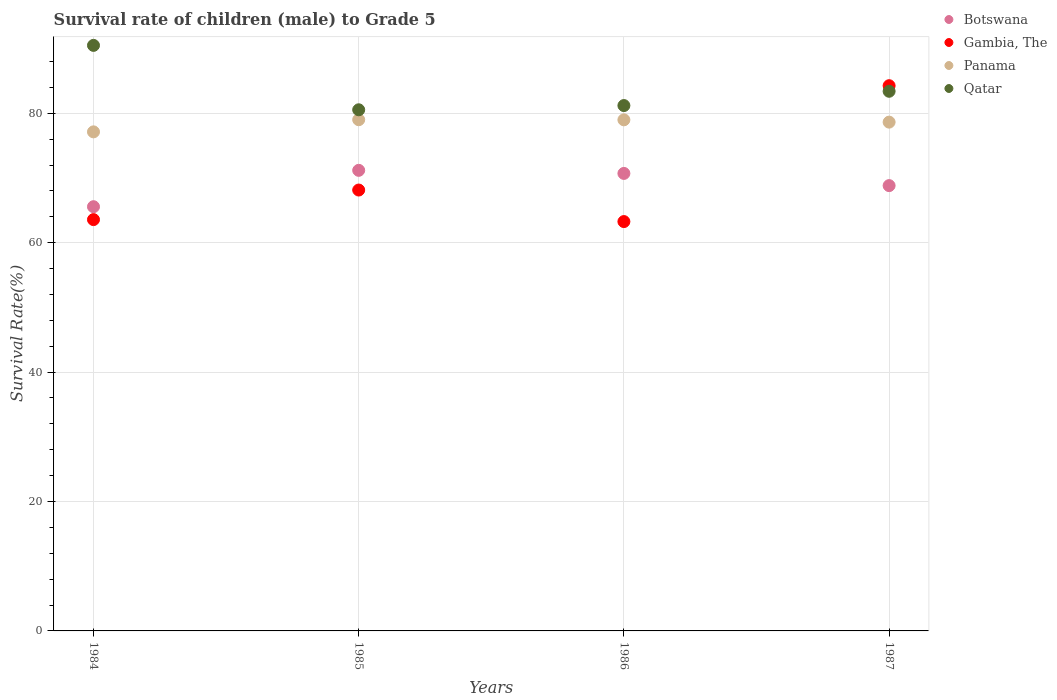How many different coloured dotlines are there?
Offer a very short reply. 4. Is the number of dotlines equal to the number of legend labels?
Your answer should be very brief. Yes. What is the survival rate of male children to grade 5 in Panama in 1987?
Offer a very short reply. 78.63. Across all years, what is the maximum survival rate of male children to grade 5 in Botswana?
Your response must be concise. 71.18. Across all years, what is the minimum survival rate of male children to grade 5 in Botswana?
Provide a succinct answer. 65.56. In which year was the survival rate of male children to grade 5 in Qatar maximum?
Provide a short and direct response. 1984. In which year was the survival rate of male children to grade 5 in Qatar minimum?
Ensure brevity in your answer.  1985. What is the total survival rate of male children to grade 5 in Panama in the graph?
Make the answer very short. 313.76. What is the difference between the survival rate of male children to grade 5 in Gambia, The in 1984 and that in 1987?
Ensure brevity in your answer.  -20.7. What is the difference between the survival rate of male children to grade 5 in Gambia, The in 1984 and the survival rate of male children to grade 5 in Panama in 1986?
Provide a succinct answer. -15.42. What is the average survival rate of male children to grade 5 in Qatar per year?
Offer a very short reply. 83.91. In the year 1986, what is the difference between the survival rate of male children to grade 5 in Panama and survival rate of male children to grade 5 in Qatar?
Your answer should be very brief. -2.21. What is the ratio of the survival rate of male children to grade 5 in Gambia, The in 1985 to that in 1987?
Your answer should be very brief. 0.81. Is the survival rate of male children to grade 5 in Qatar in 1984 less than that in 1986?
Give a very brief answer. No. Is the difference between the survival rate of male children to grade 5 in Panama in 1984 and 1987 greater than the difference between the survival rate of male children to grade 5 in Qatar in 1984 and 1987?
Provide a succinct answer. No. What is the difference between the highest and the second highest survival rate of male children to grade 5 in Panama?
Offer a very short reply. 0.02. What is the difference between the highest and the lowest survival rate of male children to grade 5 in Panama?
Your response must be concise. 1.88. In how many years, is the survival rate of male children to grade 5 in Gambia, The greater than the average survival rate of male children to grade 5 in Gambia, The taken over all years?
Provide a succinct answer. 1. Is it the case that in every year, the sum of the survival rate of male children to grade 5 in Qatar and survival rate of male children to grade 5 in Panama  is greater than the survival rate of male children to grade 5 in Botswana?
Make the answer very short. Yes. Does the survival rate of male children to grade 5 in Botswana monotonically increase over the years?
Offer a very short reply. No. Is the survival rate of male children to grade 5 in Botswana strictly greater than the survival rate of male children to grade 5 in Qatar over the years?
Keep it short and to the point. No. How many dotlines are there?
Ensure brevity in your answer.  4. How many years are there in the graph?
Keep it short and to the point. 4. What is the difference between two consecutive major ticks on the Y-axis?
Offer a terse response. 20. Are the values on the major ticks of Y-axis written in scientific E-notation?
Ensure brevity in your answer.  No. Does the graph contain any zero values?
Give a very brief answer. No. Where does the legend appear in the graph?
Offer a terse response. Top right. How are the legend labels stacked?
Offer a terse response. Vertical. What is the title of the graph?
Your answer should be compact. Survival rate of children (male) to Grade 5. What is the label or title of the Y-axis?
Give a very brief answer. Survival Rate(%). What is the Survival Rate(%) in Botswana in 1984?
Your answer should be very brief. 65.56. What is the Survival Rate(%) in Gambia, The in 1984?
Provide a short and direct response. 63.57. What is the Survival Rate(%) of Panama in 1984?
Your answer should be compact. 77.13. What is the Survival Rate(%) in Qatar in 1984?
Ensure brevity in your answer.  90.49. What is the Survival Rate(%) of Botswana in 1985?
Give a very brief answer. 71.18. What is the Survival Rate(%) of Gambia, The in 1985?
Offer a terse response. 68.14. What is the Survival Rate(%) of Panama in 1985?
Make the answer very short. 79.01. What is the Survival Rate(%) in Qatar in 1985?
Ensure brevity in your answer.  80.54. What is the Survival Rate(%) of Botswana in 1986?
Ensure brevity in your answer.  70.71. What is the Survival Rate(%) in Gambia, The in 1986?
Ensure brevity in your answer.  63.26. What is the Survival Rate(%) in Panama in 1986?
Offer a very short reply. 78.99. What is the Survival Rate(%) in Qatar in 1986?
Offer a terse response. 81.19. What is the Survival Rate(%) in Botswana in 1987?
Ensure brevity in your answer.  68.82. What is the Survival Rate(%) in Gambia, The in 1987?
Give a very brief answer. 84.26. What is the Survival Rate(%) in Panama in 1987?
Your response must be concise. 78.63. What is the Survival Rate(%) of Qatar in 1987?
Your answer should be very brief. 83.4. Across all years, what is the maximum Survival Rate(%) of Botswana?
Keep it short and to the point. 71.18. Across all years, what is the maximum Survival Rate(%) in Gambia, The?
Provide a succinct answer. 84.26. Across all years, what is the maximum Survival Rate(%) of Panama?
Your answer should be very brief. 79.01. Across all years, what is the maximum Survival Rate(%) in Qatar?
Provide a succinct answer. 90.49. Across all years, what is the minimum Survival Rate(%) in Botswana?
Provide a short and direct response. 65.56. Across all years, what is the minimum Survival Rate(%) of Gambia, The?
Your answer should be very brief. 63.26. Across all years, what is the minimum Survival Rate(%) of Panama?
Offer a very short reply. 77.13. Across all years, what is the minimum Survival Rate(%) in Qatar?
Your answer should be very brief. 80.54. What is the total Survival Rate(%) in Botswana in the graph?
Your response must be concise. 276.27. What is the total Survival Rate(%) of Gambia, The in the graph?
Provide a succinct answer. 279.23. What is the total Survival Rate(%) of Panama in the graph?
Make the answer very short. 313.76. What is the total Survival Rate(%) in Qatar in the graph?
Make the answer very short. 335.63. What is the difference between the Survival Rate(%) in Botswana in 1984 and that in 1985?
Give a very brief answer. -5.62. What is the difference between the Survival Rate(%) of Gambia, The in 1984 and that in 1985?
Provide a succinct answer. -4.57. What is the difference between the Survival Rate(%) of Panama in 1984 and that in 1985?
Make the answer very short. -1.88. What is the difference between the Survival Rate(%) of Qatar in 1984 and that in 1985?
Provide a succinct answer. 9.95. What is the difference between the Survival Rate(%) in Botswana in 1984 and that in 1986?
Ensure brevity in your answer.  -5.14. What is the difference between the Survival Rate(%) of Gambia, The in 1984 and that in 1986?
Your answer should be compact. 0.3. What is the difference between the Survival Rate(%) in Panama in 1984 and that in 1986?
Your answer should be very brief. -1.86. What is the difference between the Survival Rate(%) of Qatar in 1984 and that in 1986?
Keep it short and to the point. 9.3. What is the difference between the Survival Rate(%) in Botswana in 1984 and that in 1987?
Offer a terse response. -3.26. What is the difference between the Survival Rate(%) in Gambia, The in 1984 and that in 1987?
Offer a terse response. -20.7. What is the difference between the Survival Rate(%) in Panama in 1984 and that in 1987?
Ensure brevity in your answer.  -1.5. What is the difference between the Survival Rate(%) of Qatar in 1984 and that in 1987?
Provide a succinct answer. 7.09. What is the difference between the Survival Rate(%) of Botswana in 1985 and that in 1986?
Provide a short and direct response. 0.48. What is the difference between the Survival Rate(%) of Gambia, The in 1985 and that in 1986?
Provide a short and direct response. 4.87. What is the difference between the Survival Rate(%) in Panama in 1985 and that in 1986?
Offer a terse response. 0.02. What is the difference between the Survival Rate(%) of Qatar in 1985 and that in 1986?
Ensure brevity in your answer.  -0.65. What is the difference between the Survival Rate(%) in Botswana in 1985 and that in 1987?
Give a very brief answer. 2.36. What is the difference between the Survival Rate(%) of Gambia, The in 1985 and that in 1987?
Your answer should be compact. -16.12. What is the difference between the Survival Rate(%) of Panama in 1985 and that in 1987?
Your answer should be very brief. 0.37. What is the difference between the Survival Rate(%) in Qatar in 1985 and that in 1987?
Ensure brevity in your answer.  -2.86. What is the difference between the Survival Rate(%) in Botswana in 1986 and that in 1987?
Give a very brief answer. 1.88. What is the difference between the Survival Rate(%) in Gambia, The in 1986 and that in 1987?
Your answer should be compact. -21. What is the difference between the Survival Rate(%) in Panama in 1986 and that in 1987?
Your answer should be very brief. 0.36. What is the difference between the Survival Rate(%) in Qatar in 1986 and that in 1987?
Give a very brief answer. -2.21. What is the difference between the Survival Rate(%) in Botswana in 1984 and the Survival Rate(%) in Gambia, The in 1985?
Your answer should be very brief. -2.58. What is the difference between the Survival Rate(%) in Botswana in 1984 and the Survival Rate(%) in Panama in 1985?
Provide a succinct answer. -13.45. What is the difference between the Survival Rate(%) of Botswana in 1984 and the Survival Rate(%) of Qatar in 1985?
Your answer should be very brief. -14.98. What is the difference between the Survival Rate(%) of Gambia, The in 1984 and the Survival Rate(%) of Panama in 1985?
Provide a short and direct response. -15.44. What is the difference between the Survival Rate(%) of Gambia, The in 1984 and the Survival Rate(%) of Qatar in 1985?
Your answer should be very brief. -16.97. What is the difference between the Survival Rate(%) in Panama in 1984 and the Survival Rate(%) in Qatar in 1985?
Keep it short and to the point. -3.41. What is the difference between the Survival Rate(%) in Botswana in 1984 and the Survival Rate(%) in Gambia, The in 1986?
Offer a very short reply. 2.3. What is the difference between the Survival Rate(%) of Botswana in 1984 and the Survival Rate(%) of Panama in 1986?
Provide a succinct answer. -13.43. What is the difference between the Survival Rate(%) in Botswana in 1984 and the Survival Rate(%) in Qatar in 1986?
Your answer should be very brief. -15.63. What is the difference between the Survival Rate(%) of Gambia, The in 1984 and the Survival Rate(%) of Panama in 1986?
Keep it short and to the point. -15.42. What is the difference between the Survival Rate(%) in Gambia, The in 1984 and the Survival Rate(%) in Qatar in 1986?
Offer a terse response. -17.63. What is the difference between the Survival Rate(%) of Panama in 1984 and the Survival Rate(%) of Qatar in 1986?
Provide a short and direct response. -4.07. What is the difference between the Survival Rate(%) of Botswana in 1984 and the Survival Rate(%) of Gambia, The in 1987?
Keep it short and to the point. -18.7. What is the difference between the Survival Rate(%) in Botswana in 1984 and the Survival Rate(%) in Panama in 1987?
Make the answer very short. -13.07. What is the difference between the Survival Rate(%) in Botswana in 1984 and the Survival Rate(%) in Qatar in 1987?
Offer a very short reply. -17.84. What is the difference between the Survival Rate(%) in Gambia, The in 1984 and the Survival Rate(%) in Panama in 1987?
Give a very brief answer. -15.07. What is the difference between the Survival Rate(%) of Gambia, The in 1984 and the Survival Rate(%) of Qatar in 1987?
Make the answer very short. -19.83. What is the difference between the Survival Rate(%) of Panama in 1984 and the Survival Rate(%) of Qatar in 1987?
Offer a very short reply. -6.27. What is the difference between the Survival Rate(%) of Botswana in 1985 and the Survival Rate(%) of Gambia, The in 1986?
Make the answer very short. 7.92. What is the difference between the Survival Rate(%) of Botswana in 1985 and the Survival Rate(%) of Panama in 1986?
Ensure brevity in your answer.  -7.81. What is the difference between the Survival Rate(%) in Botswana in 1985 and the Survival Rate(%) in Qatar in 1986?
Your response must be concise. -10.01. What is the difference between the Survival Rate(%) in Gambia, The in 1985 and the Survival Rate(%) in Panama in 1986?
Ensure brevity in your answer.  -10.85. What is the difference between the Survival Rate(%) of Gambia, The in 1985 and the Survival Rate(%) of Qatar in 1986?
Make the answer very short. -13.06. What is the difference between the Survival Rate(%) of Panama in 1985 and the Survival Rate(%) of Qatar in 1986?
Your answer should be very brief. -2.19. What is the difference between the Survival Rate(%) of Botswana in 1985 and the Survival Rate(%) of Gambia, The in 1987?
Offer a very short reply. -13.08. What is the difference between the Survival Rate(%) of Botswana in 1985 and the Survival Rate(%) of Panama in 1987?
Give a very brief answer. -7.45. What is the difference between the Survival Rate(%) in Botswana in 1985 and the Survival Rate(%) in Qatar in 1987?
Make the answer very short. -12.22. What is the difference between the Survival Rate(%) of Gambia, The in 1985 and the Survival Rate(%) of Panama in 1987?
Make the answer very short. -10.49. What is the difference between the Survival Rate(%) in Gambia, The in 1985 and the Survival Rate(%) in Qatar in 1987?
Provide a succinct answer. -15.26. What is the difference between the Survival Rate(%) of Panama in 1985 and the Survival Rate(%) of Qatar in 1987?
Your answer should be compact. -4.39. What is the difference between the Survival Rate(%) of Botswana in 1986 and the Survival Rate(%) of Gambia, The in 1987?
Offer a very short reply. -13.56. What is the difference between the Survival Rate(%) in Botswana in 1986 and the Survival Rate(%) in Panama in 1987?
Your response must be concise. -7.93. What is the difference between the Survival Rate(%) of Botswana in 1986 and the Survival Rate(%) of Qatar in 1987?
Your response must be concise. -12.69. What is the difference between the Survival Rate(%) of Gambia, The in 1986 and the Survival Rate(%) of Panama in 1987?
Offer a very short reply. -15.37. What is the difference between the Survival Rate(%) of Gambia, The in 1986 and the Survival Rate(%) of Qatar in 1987?
Keep it short and to the point. -20.14. What is the difference between the Survival Rate(%) in Panama in 1986 and the Survival Rate(%) in Qatar in 1987?
Keep it short and to the point. -4.41. What is the average Survival Rate(%) in Botswana per year?
Your response must be concise. 69.07. What is the average Survival Rate(%) of Gambia, The per year?
Your response must be concise. 69.81. What is the average Survival Rate(%) in Panama per year?
Your answer should be compact. 78.44. What is the average Survival Rate(%) of Qatar per year?
Your answer should be very brief. 83.91. In the year 1984, what is the difference between the Survival Rate(%) of Botswana and Survival Rate(%) of Gambia, The?
Your response must be concise. 1.99. In the year 1984, what is the difference between the Survival Rate(%) of Botswana and Survival Rate(%) of Panama?
Provide a succinct answer. -11.57. In the year 1984, what is the difference between the Survival Rate(%) in Botswana and Survival Rate(%) in Qatar?
Your response must be concise. -24.93. In the year 1984, what is the difference between the Survival Rate(%) of Gambia, The and Survival Rate(%) of Panama?
Give a very brief answer. -13.56. In the year 1984, what is the difference between the Survival Rate(%) in Gambia, The and Survival Rate(%) in Qatar?
Your answer should be very brief. -26.93. In the year 1984, what is the difference between the Survival Rate(%) of Panama and Survival Rate(%) of Qatar?
Keep it short and to the point. -13.36. In the year 1985, what is the difference between the Survival Rate(%) of Botswana and Survival Rate(%) of Gambia, The?
Offer a terse response. 3.04. In the year 1985, what is the difference between the Survival Rate(%) in Botswana and Survival Rate(%) in Panama?
Give a very brief answer. -7.82. In the year 1985, what is the difference between the Survival Rate(%) in Botswana and Survival Rate(%) in Qatar?
Provide a succinct answer. -9.36. In the year 1985, what is the difference between the Survival Rate(%) in Gambia, The and Survival Rate(%) in Panama?
Your answer should be compact. -10.87. In the year 1985, what is the difference between the Survival Rate(%) of Gambia, The and Survival Rate(%) of Qatar?
Your answer should be very brief. -12.4. In the year 1985, what is the difference between the Survival Rate(%) in Panama and Survival Rate(%) in Qatar?
Provide a succinct answer. -1.53. In the year 1986, what is the difference between the Survival Rate(%) in Botswana and Survival Rate(%) in Gambia, The?
Offer a very short reply. 7.44. In the year 1986, what is the difference between the Survival Rate(%) in Botswana and Survival Rate(%) in Panama?
Provide a succinct answer. -8.28. In the year 1986, what is the difference between the Survival Rate(%) in Botswana and Survival Rate(%) in Qatar?
Keep it short and to the point. -10.49. In the year 1986, what is the difference between the Survival Rate(%) of Gambia, The and Survival Rate(%) of Panama?
Ensure brevity in your answer.  -15.72. In the year 1986, what is the difference between the Survival Rate(%) in Gambia, The and Survival Rate(%) in Qatar?
Provide a succinct answer. -17.93. In the year 1986, what is the difference between the Survival Rate(%) in Panama and Survival Rate(%) in Qatar?
Give a very brief answer. -2.21. In the year 1987, what is the difference between the Survival Rate(%) of Botswana and Survival Rate(%) of Gambia, The?
Ensure brevity in your answer.  -15.44. In the year 1987, what is the difference between the Survival Rate(%) in Botswana and Survival Rate(%) in Panama?
Ensure brevity in your answer.  -9.81. In the year 1987, what is the difference between the Survival Rate(%) in Botswana and Survival Rate(%) in Qatar?
Provide a short and direct response. -14.58. In the year 1987, what is the difference between the Survival Rate(%) of Gambia, The and Survival Rate(%) of Panama?
Your answer should be very brief. 5.63. In the year 1987, what is the difference between the Survival Rate(%) of Gambia, The and Survival Rate(%) of Qatar?
Provide a short and direct response. 0.86. In the year 1987, what is the difference between the Survival Rate(%) in Panama and Survival Rate(%) in Qatar?
Your response must be concise. -4.77. What is the ratio of the Survival Rate(%) of Botswana in 1984 to that in 1985?
Make the answer very short. 0.92. What is the ratio of the Survival Rate(%) of Gambia, The in 1984 to that in 1985?
Offer a terse response. 0.93. What is the ratio of the Survival Rate(%) in Panama in 1984 to that in 1985?
Ensure brevity in your answer.  0.98. What is the ratio of the Survival Rate(%) in Qatar in 1984 to that in 1985?
Offer a very short reply. 1.12. What is the ratio of the Survival Rate(%) in Botswana in 1984 to that in 1986?
Offer a terse response. 0.93. What is the ratio of the Survival Rate(%) of Gambia, The in 1984 to that in 1986?
Offer a terse response. 1. What is the ratio of the Survival Rate(%) in Panama in 1984 to that in 1986?
Give a very brief answer. 0.98. What is the ratio of the Survival Rate(%) in Qatar in 1984 to that in 1986?
Give a very brief answer. 1.11. What is the ratio of the Survival Rate(%) of Botswana in 1984 to that in 1987?
Offer a terse response. 0.95. What is the ratio of the Survival Rate(%) in Gambia, The in 1984 to that in 1987?
Give a very brief answer. 0.75. What is the ratio of the Survival Rate(%) of Panama in 1984 to that in 1987?
Your response must be concise. 0.98. What is the ratio of the Survival Rate(%) of Qatar in 1984 to that in 1987?
Give a very brief answer. 1.08. What is the ratio of the Survival Rate(%) of Gambia, The in 1985 to that in 1986?
Ensure brevity in your answer.  1.08. What is the ratio of the Survival Rate(%) of Botswana in 1985 to that in 1987?
Make the answer very short. 1.03. What is the ratio of the Survival Rate(%) of Gambia, The in 1985 to that in 1987?
Offer a very short reply. 0.81. What is the ratio of the Survival Rate(%) in Panama in 1985 to that in 1987?
Make the answer very short. 1. What is the ratio of the Survival Rate(%) in Qatar in 1985 to that in 1987?
Your answer should be very brief. 0.97. What is the ratio of the Survival Rate(%) of Botswana in 1986 to that in 1987?
Provide a short and direct response. 1.03. What is the ratio of the Survival Rate(%) of Gambia, The in 1986 to that in 1987?
Give a very brief answer. 0.75. What is the ratio of the Survival Rate(%) in Panama in 1986 to that in 1987?
Your answer should be compact. 1. What is the ratio of the Survival Rate(%) in Qatar in 1986 to that in 1987?
Offer a very short reply. 0.97. What is the difference between the highest and the second highest Survival Rate(%) in Botswana?
Your answer should be compact. 0.48. What is the difference between the highest and the second highest Survival Rate(%) of Gambia, The?
Offer a very short reply. 16.12. What is the difference between the highest and the second highest Survival Rate(%) in Panama?
Provide a short and direct response. 0.02. What is the difference between the highest and the second highest Survival Rate(%) of Qatar?
Ensure brevity in your answer.  7.09. What is the difference between the highest and the lowest Survival Rate(%) of Botswana?
Offer a very short reply. 5.62. What is the difference between the highest and the lowest Survival Rate(%) of Gambia, The?
Provide a succinct answer. 21. What is the difference between the highest and the lowest Survival Rate(%) of Panama?
Provide a short and direct response. 1.88. What is the difference between the highest and the lowest Survival Rate(%) of Qatar?
Your response must be concise. 9.95. 